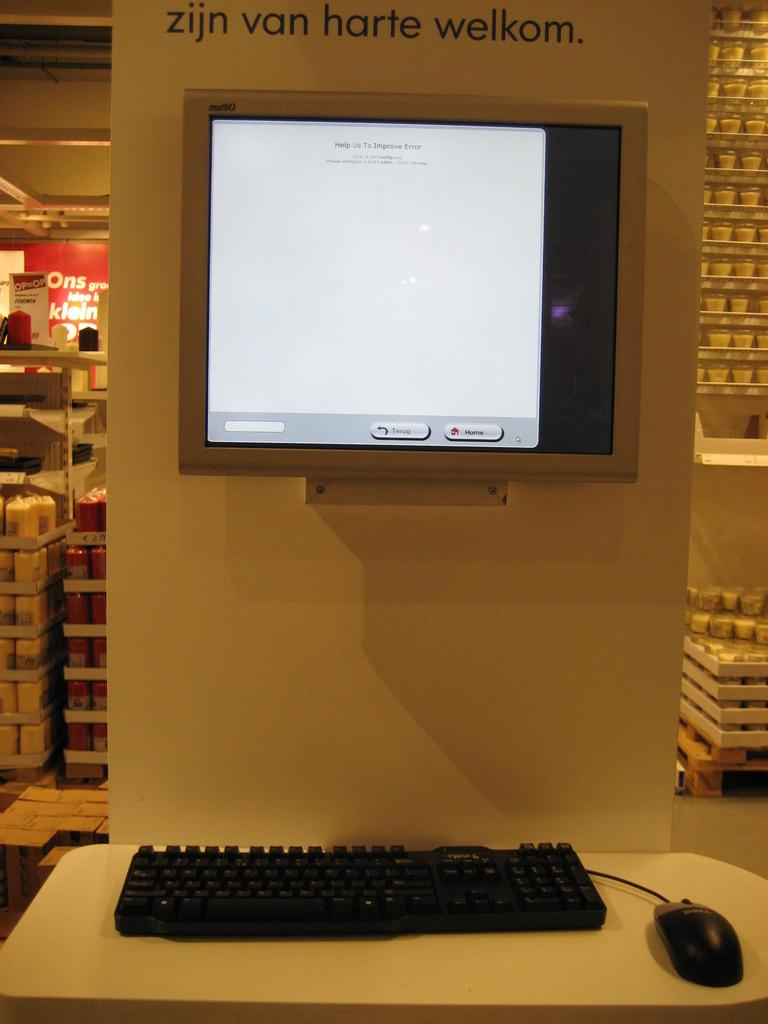<image>
Describe the image concisely. A computer monitor displays an error message on screen. 